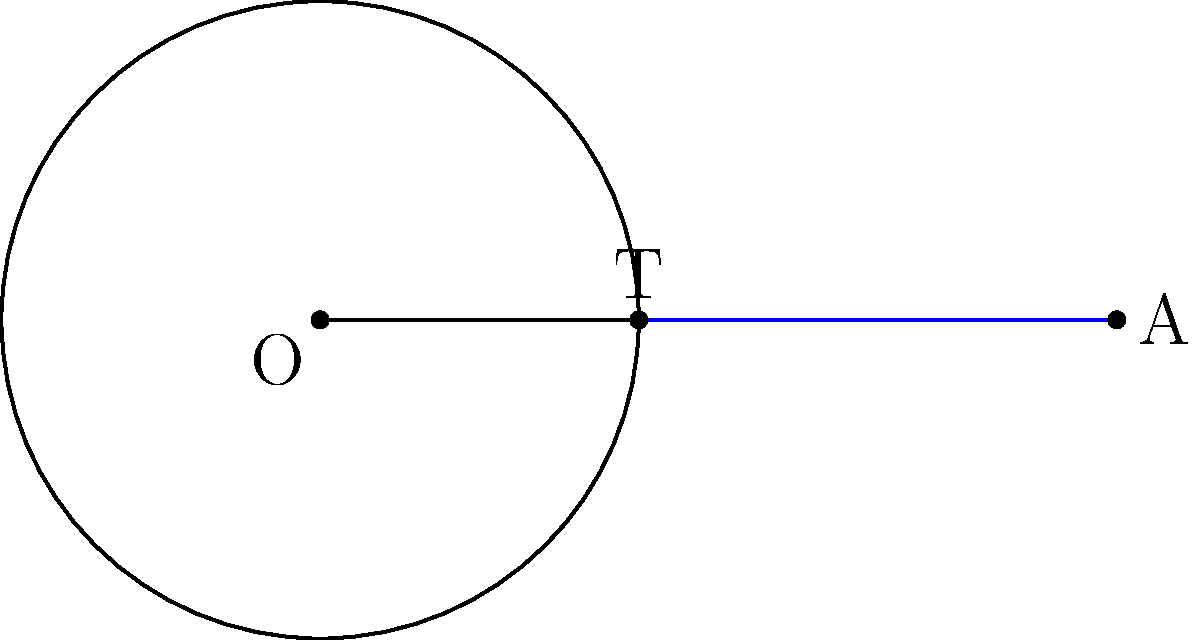In the diagram, $O$ is the center of the circle with radius $r$, and $A$ is an external point. If $OA = 5$ units and the length of the tangent line $AT$ is $4$ units, determine the radius $r$ of the circle. Let's approach this step-by-step:

1) In a circle, a tangent line is perpendicular to the radius at the point of tangency. This forms a right triangle OAT.

2) We can apply the Pythagorean theorem to this right triangle:

   $OA^2 = OT^2 + AT^2$

3) We know that:
   - $OA = 5$ (given)
   - $AT = 4$ (given)
   - $OT = r$ (radius of the circle)

4) Substituting these into the Pythagorean theorem:

   $5^2 = r^2 + 4^2$

5) Simplify:

   $25 = r^2 + 16$

6) Subtract 16 from both sides:

   $9 = r^2$

7) Take the square root of both sides:

   $r = 3$

Therefore, the radius of the circle is 3 units.
Answer: $3$ units 